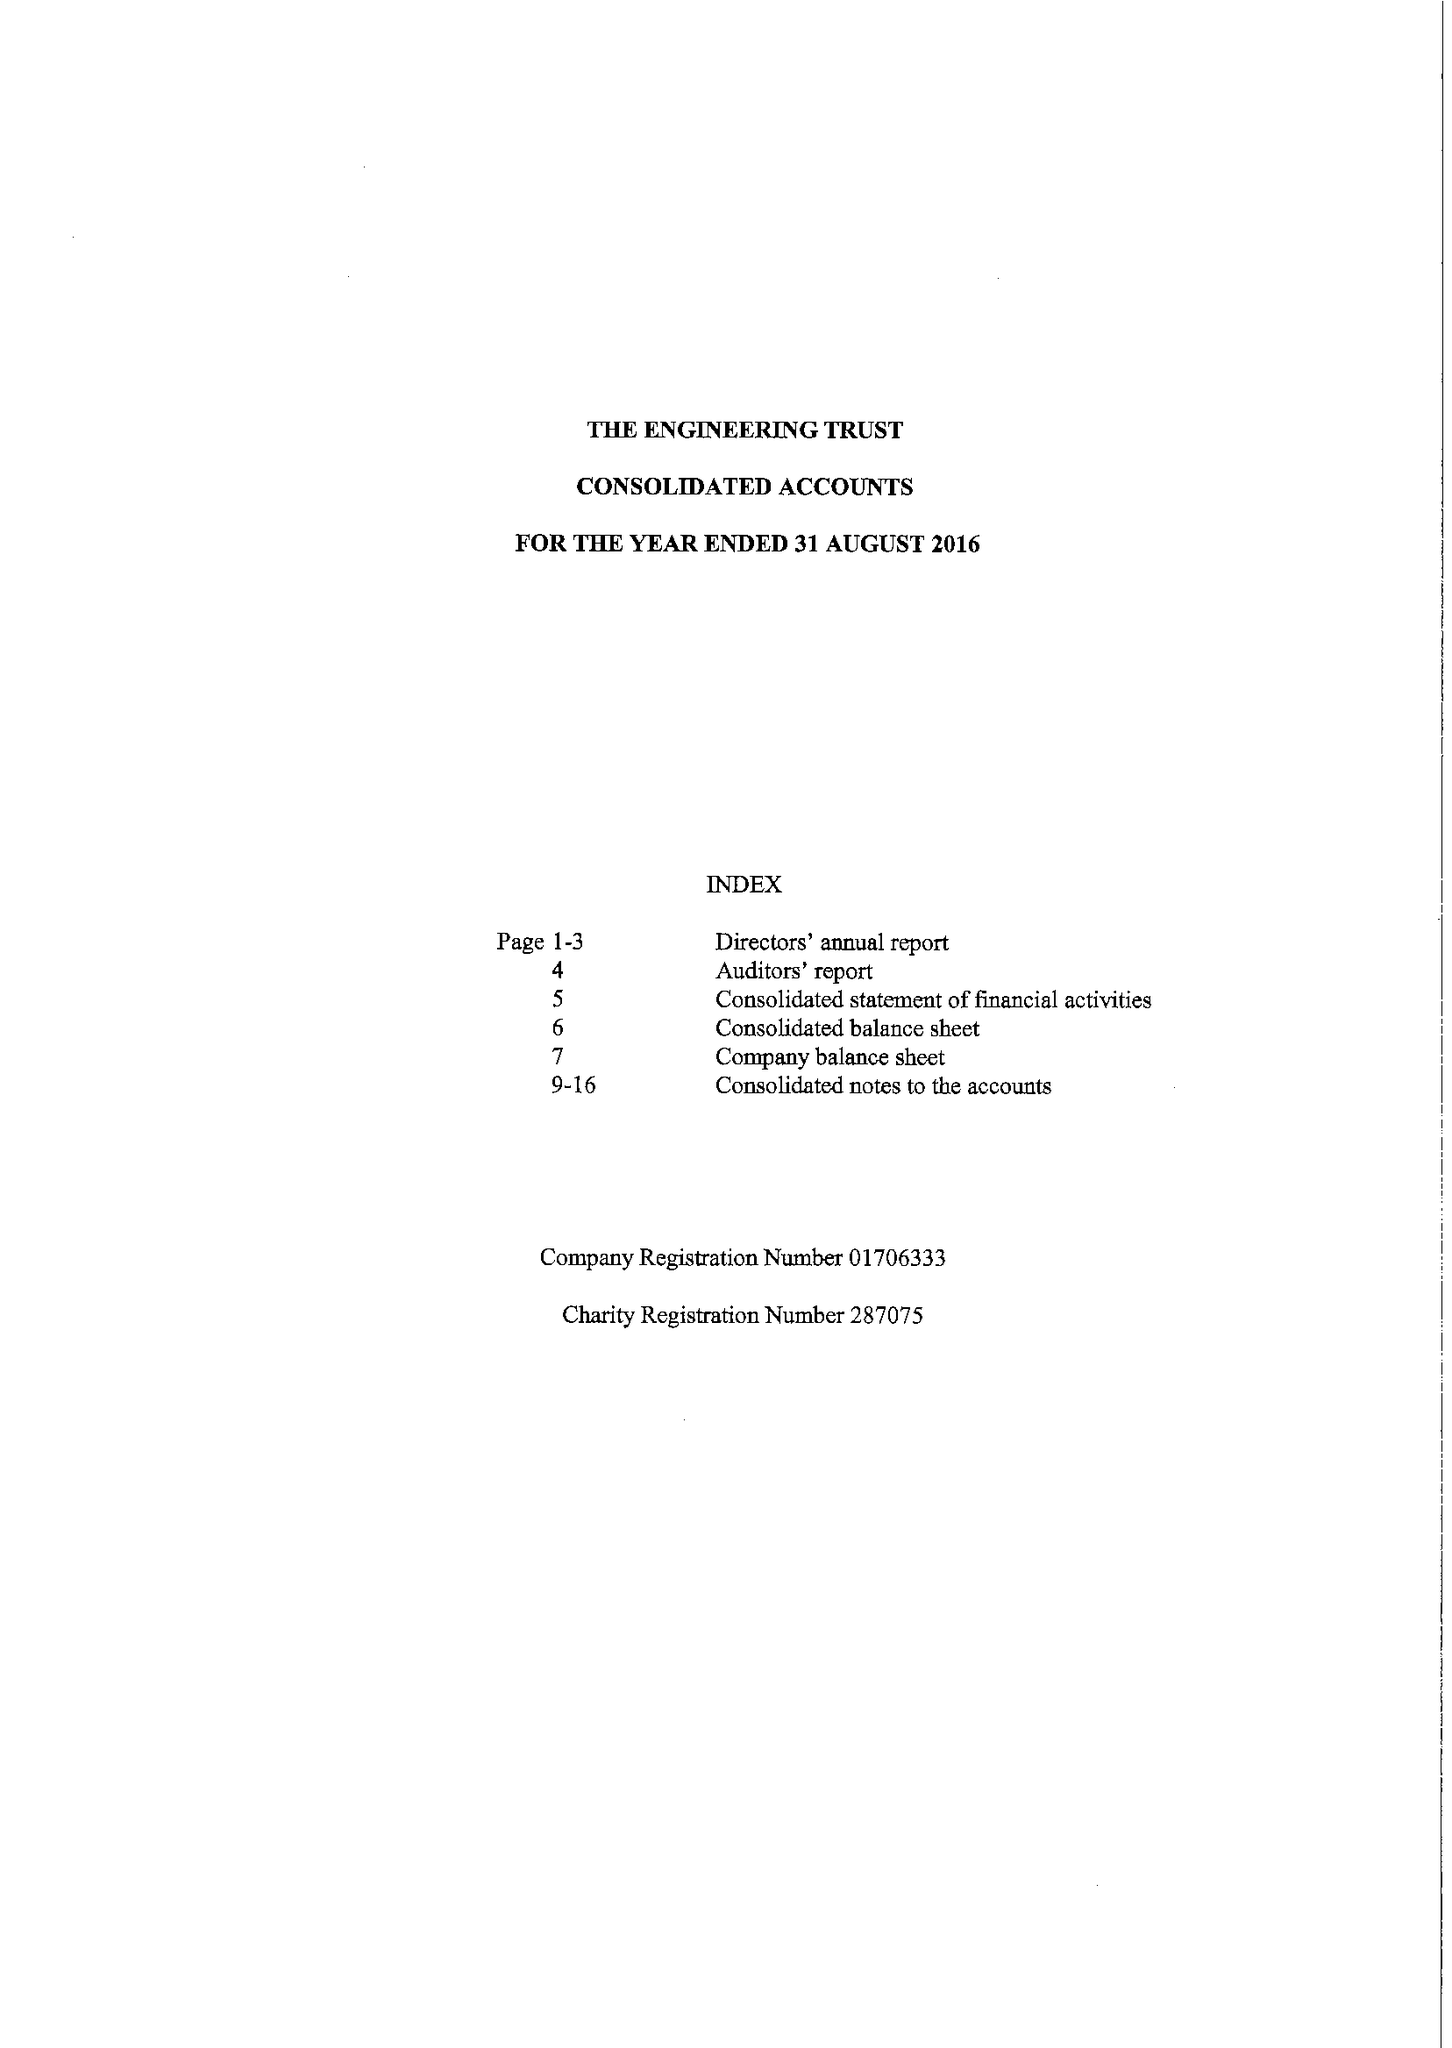What is the value for the report_date?
Answer the question using a single word or phrase. 2016-08-31 